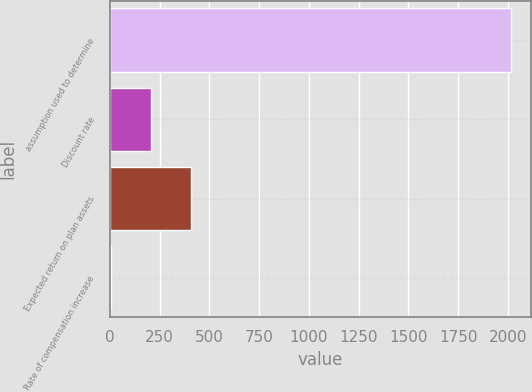Convert chart to OTSL. <chart><loc_0><loc_0><loc_500><loc_500><bar_chart><fcel>assumption used to determine<fcel>Discount rate<fcel>Expected return on plan assets<fcel>Rate of compensation increase<nl><fcel>2014<fcel>204.33<fcel>405.41<fcel>3.25<nl></chart> 